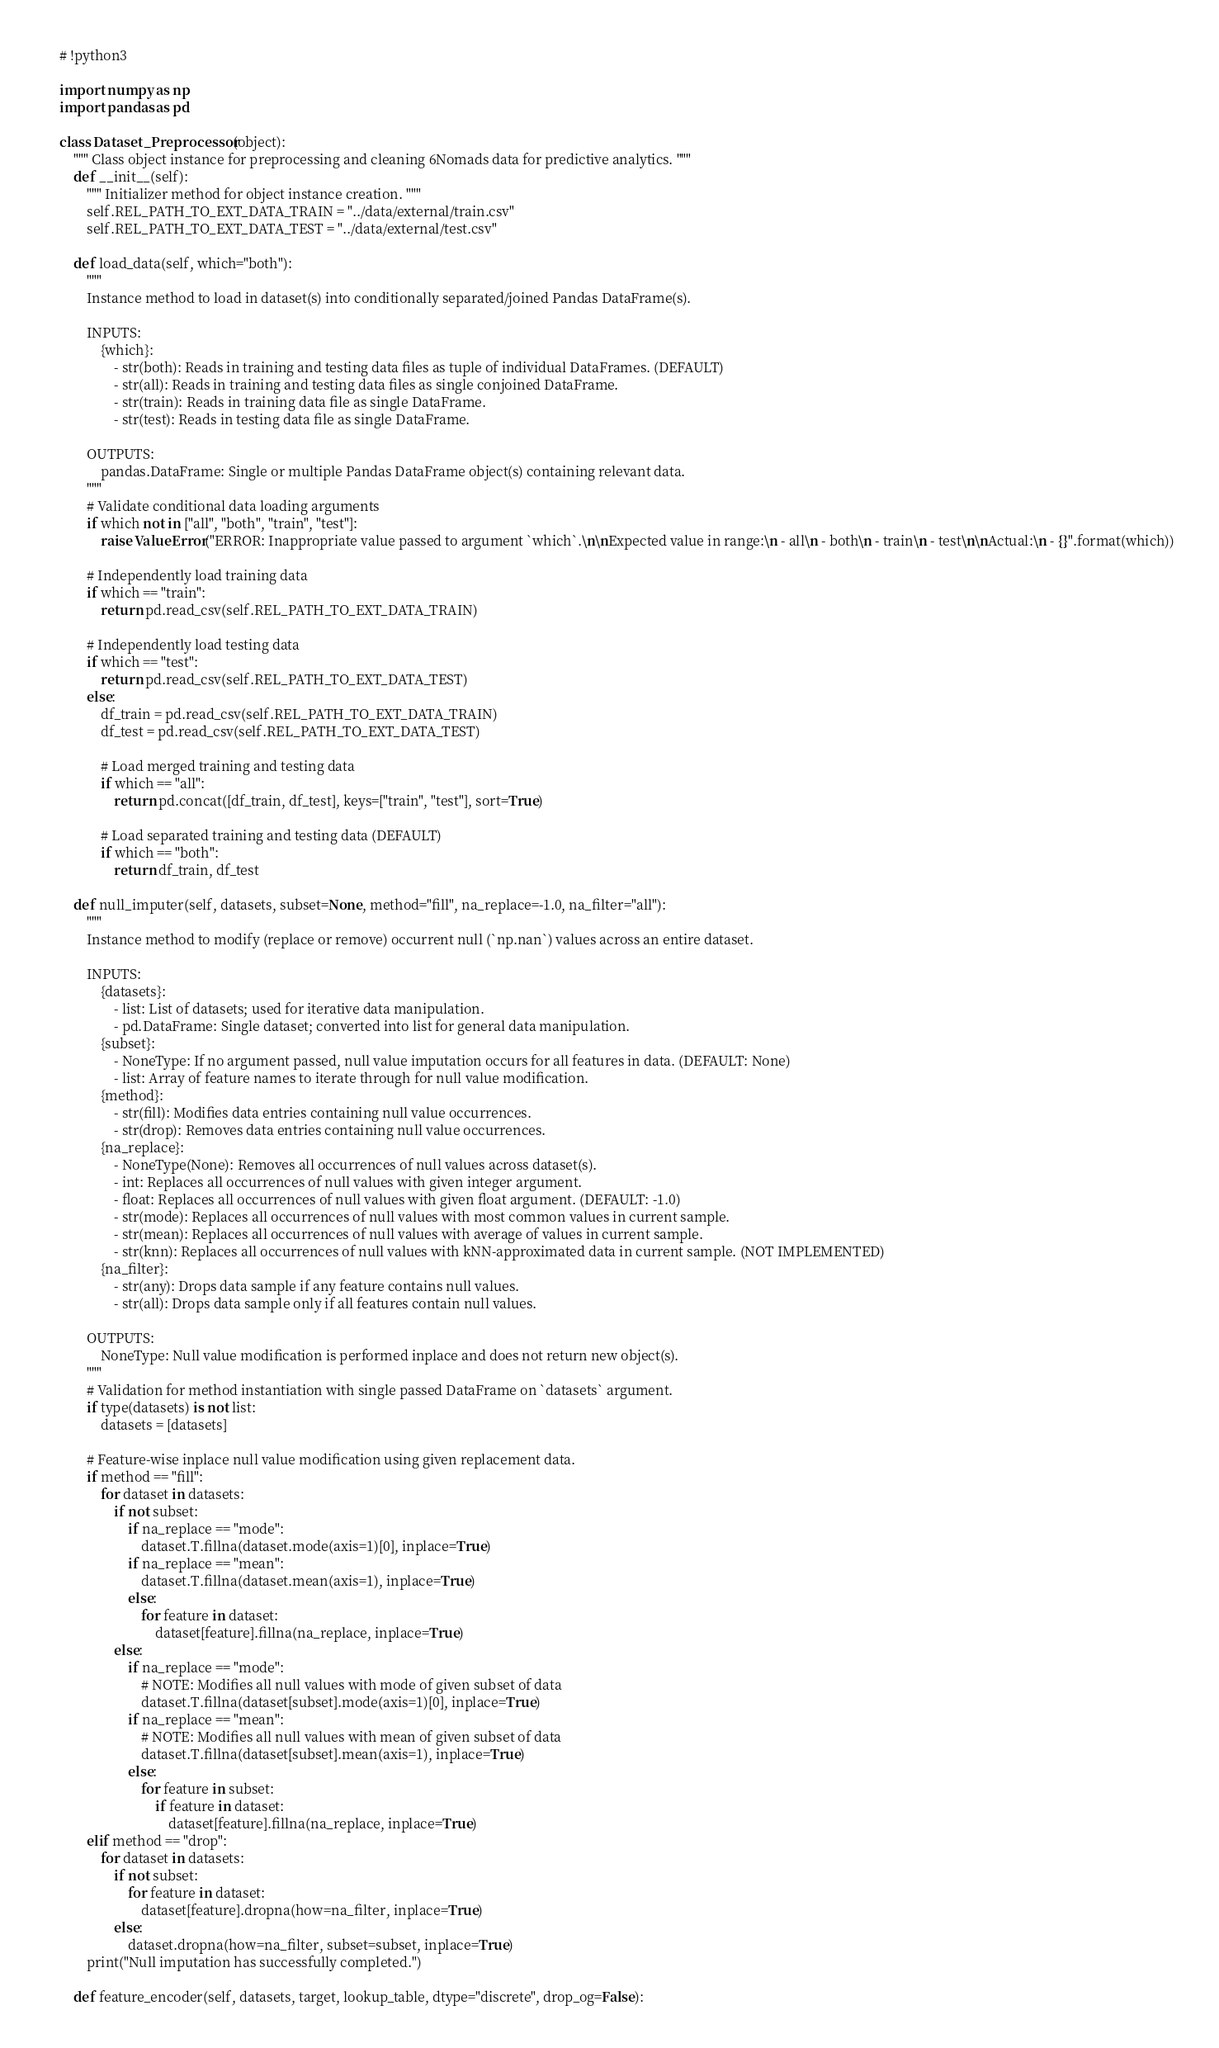<code> <loc_0><loc_0><loc_500><loc_500><_Python_># !python3

import numpy as np
import pandas as pd

class Dataset_Preprocessor(object):
    """ Class object instance for preprocessing and cleaning 6Nomads data for predictive analytics. """
    def __init__(self):
        """ Initializer method for object instance creation. """
        self.REL_PATH_TO_EXT_DATA_TRAIN = "../data/external/train.csv"
        self.REL_PATH_TO_EXT_DATA_TEST = "../data/external/test.csv"
        
    def load_data(self, which="both"):
        """ 
        Instance method to load in dataset(s) into conditionally separated/joined Pandas DataFrame(s). 
        
        INPUTS:
            {which}:
                - str(both): Reads in training and testing data files as tuple of individual DataFrames. (DEFAULT)
                - str(all): Reads in training and testing data files as single conjoined DataFrame.
                - str(train): Reads in training data file as single DataFrame.
                - str(test): Reads in testing data file as single DataFrame.
                
        OUTPUTS:
            pandas.DataFrame: Single or multiple Pandas DataFrame object(s) containing relevant data.
        """
        # Validate conditional data loading arguments
        if which not in ["all", "both", "train", "test"]:
            raise ValueError("ERROR: Inappropriate value passed to argument `which`.\n\nExpected value in range:\n - all\n - both\n - train\n - test\n\nActual:\n - {}".format(which))
        
        # Independently load training data
        if which == "train":
            return pd.read_csv(self.REL_PATH_TO_EXT_DATA_TRAIN)
        
        # Independently load testing data
        if which == "test":
            return pd.read_csv(self.REL_PATH_TO_EXT_DATA_TEST)
        else:
            df_train = pd.read_csv(self.REL_PATH_TO_EXT_DATA_TRAIN)
            df_test = pd.read_csv(self.REL_PATH_TO_EXT_DATA_TEST)
            
            # Load merged training and testing data
            if which == "all":
                return pd.concat([df_train, df_test], keys=["train", "test"], sort=True)
            
            # Load separated training and testing data (DEFAULT)
            if which == "both":
                return df_train, df_test
            
    def null_imputer(self, datasets, subset=None, method="fill", na_replace=-1.0, na_filter="all"):
        """
        Instance method to modify (replace or remove) occurrent null (`np.nan`) values across an entire dataset.
        
        INPUTS:
            {datasets}:
                - list: List of datasets; used for iterative data manipulation.
                - pd.DataFrame: Single dataset; converted into list for general data manipulation.
            {subset}:
                - NoneType: If no argument passed, null value imputation occurs for all features in data. (DEFAULT: None)
                - list: Array of feature names to iterate through for null value modification.
            {method}:
                - str(fill): Modifies data entries containing null value occurrences. 
                - str(drop): Removes data entries containing null value occurrences. 
            {na_replace}:
                - NoneType(None): Removes all occurrences of null values across dataset(s).
                - int: Replaces all occurrences of null values with given integer argument.
                - float: Replaces all occurrences of null values with given float argument. (DEFAULT: -1.0)
                - str(mode): Replaces all occurrences of null values with most common values in current sample.
                - str(mean): Replaces all occurrences of null values with average of values in current sample.
                - str(knn): Replaces all occurrences of null values with kNN-approximated data in current sample. (NOT IMPLEMENTED)
            {na_filter}:
                - str(any): Drops data sample if any feature contains null values.
                - str(all): Drops data sample only if all features contain null values.
                
        OUTPUTS:
            NoneType: Null value modification is performed inplace and does not return new object(s).
        """
        # Validation for method instantiation with single passed DataFrame on `datasets` argument.
        if type(datasets) is not list:
            datasets = [datasets]
            
        # Feature-wise inplace null value modification using given replacement data.
        if method == "fill":
            for dataset in datasets:
                if not subset:
                    if na_replace == "mode":
                        dataset.T.fillna(dataset.mode(axis=1)[0], inplace=True)
                    if na_replace == "mean":
                        dataset.T.fillna(dataset.mean(axis=1), inplace=True)
                    else:
                        for feature in dataset:
                            dataset[feature].fillna(na_replace, inplace=True)
                else:
                    if na_replace == "mode":
                        # NOTE: Modifies all null values with mode of given subset of data
                        dataset.T.fillna(dataset[subset].mode(axis=1)[0], inplace=True)
                    if na_replace == "mean":
                        # NOTE: Modifies all null values with mean of given subset of data
                        dataset.T.fillna(dataset[subset].mean(axis=1), inplace=True)
                    else:
                        for feature in subset:
                            if feature in dataset:
                                dataset[feature].fillna(na_replace, inplace=True)
        elif method == "drop":
            for dataset in datasets:
                if not subset:
                    for feature in dataset:
                        dataset[feature].dropna(how=na_filter, inplace=True)
                else:
                    dataset.dropna(how=na_filter, subset=subset, inplace=True)
        print("Null imputation has successfully completed.")
        
    def feature_encoder(self, datasets, target, lookup_table, dtype="discrete", drop_og=False):</code> 